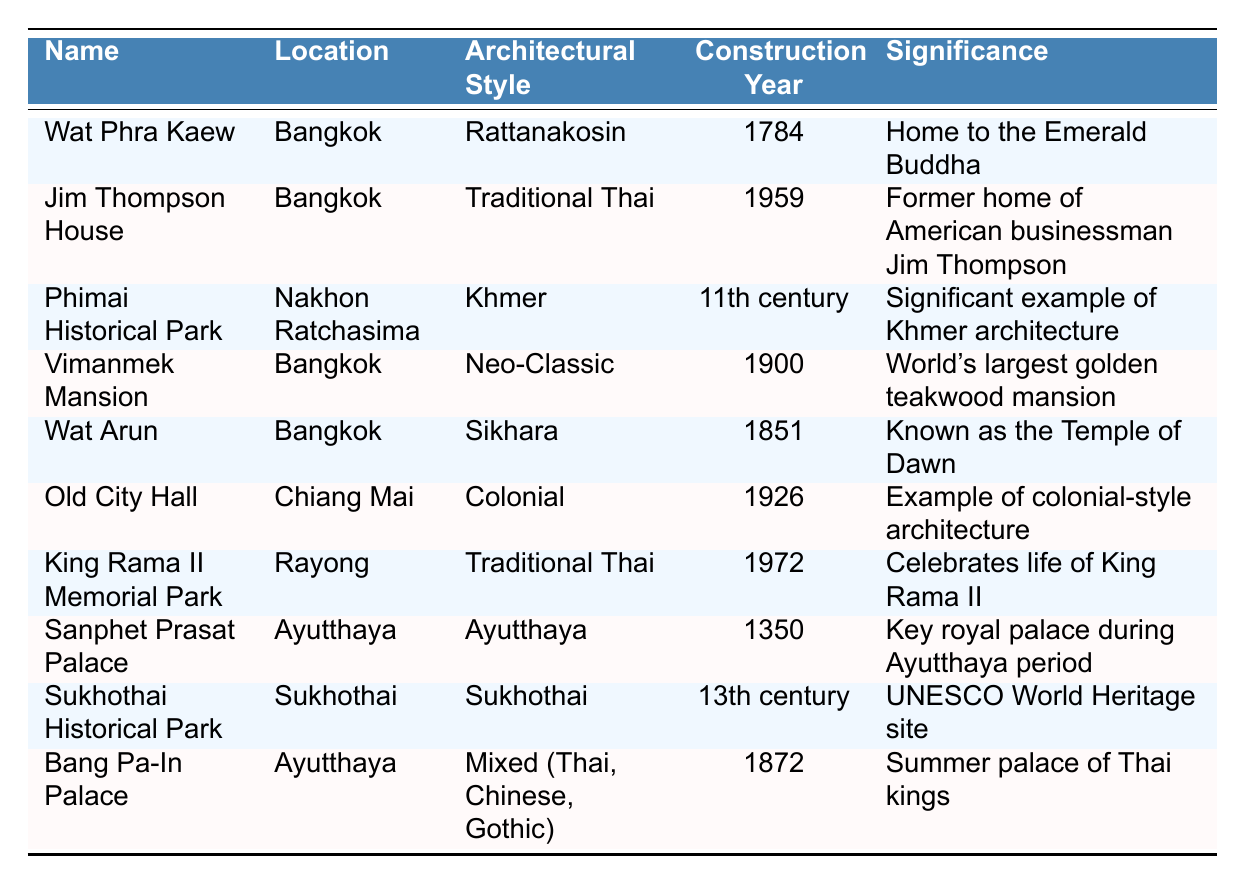What is the architectural style of Wat Phra Kaew? From the table, locate Wat Phra Kaew, and note that its architectural style is listed as Rattanakosin.
Answer: Rattanakosin In which year was the Old City Hall constructed? Locate the row for Old City Hall in the table, where it states that the construction year is 1926.
Answer: 1926 Which building is known as the Temple of Dawn? Find the relevant entry in the table for Wat Arun, which is specifically noted as being known as the Temple of Dawn.
Answer: Wat Arun How many historical buildings were constructed in the 19th century? Review the construction years in the table: Wat Arun (1851), Vimanmek Mansion (1900), Jim Thompson House (1959), and Bang Pa-In Palace (1872) are all in the 19th century or later, resulting in a total of three buildings.
Answer: 3 Is Vimanmek Mansion the world's largest golden teakwood mansion? The table indicates that Vimanmek Mansion is described as the world's largest golden teakwood mansion, thus confirming the statement as true.
Answer: Yes Which city has the most historical buildings listed in the table? Count the buildings in each location: Bangkok has 4 entries, Ayutthaya has 2, Sukhothai has 1, Chiang Mai has 1, and Nakhon Ratchasima has 1. Thus, Bangkok with 4 buildings has the most.
Answer: Bangkok What is the architectural style of King Rama II Memorial Park? By inspecting the row for King Rama II Memorial Park, it is indicated that its architectural style is Traditional Thai.
Answer: Traditional Thai Which two styles of architecture are represented in the Bang Pa-In Palace? According to the table, the architectural style of Bang Pa-In Palace is noted as Mixed (Thai, Chinese, Gothic), indicating three styles.
Answer: Thai, Chinese, Gothic What significant event did the Jim Thompson House contribute to in Thailand? The table specifies that the Jim Thompson House is significant for its role in helping to revive the Thai silk industry, which can be inferred directly from its description.
Answer: Reviving the Thai silk industry How does the architectural style of Phimai Historical Park compare to that of Sukhothai Historical Park? The table shows that Phimai Historical Park is influenced by Khmer architecture while Sukhothai Historical Park reflects early Thai architecture. Thus, they represent different cultural influences.
Answer: Different cultural influences 